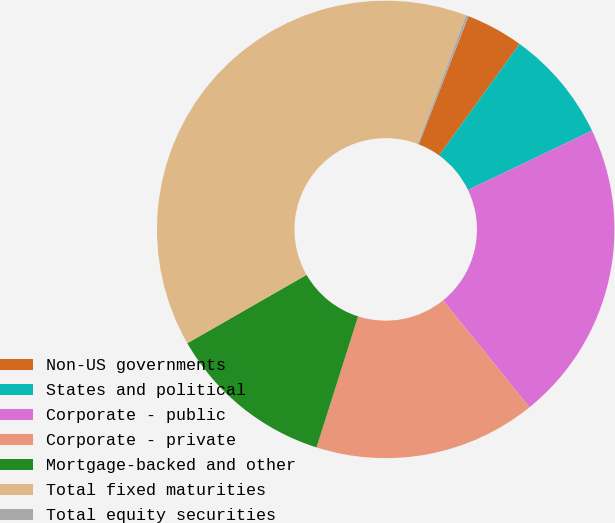Convert chart to OTSL. <chart><loc_0><loc_0><loc_500><loc_500><pie_chart><fcel>Non-US governments<fcel>States and political<fcel>Corporate - public<fcel>Corporate - private<fcel>Mortgage-backed and other<fcel>Total fixed maturities<fcel>Total equity securities<nl><fcel>4.06%<fcel>7.94%<fcel>21.29%<fcel>15.71%<fcel>11.82%<fcel>39.0%<fcel>0.18%<nl></chart> 